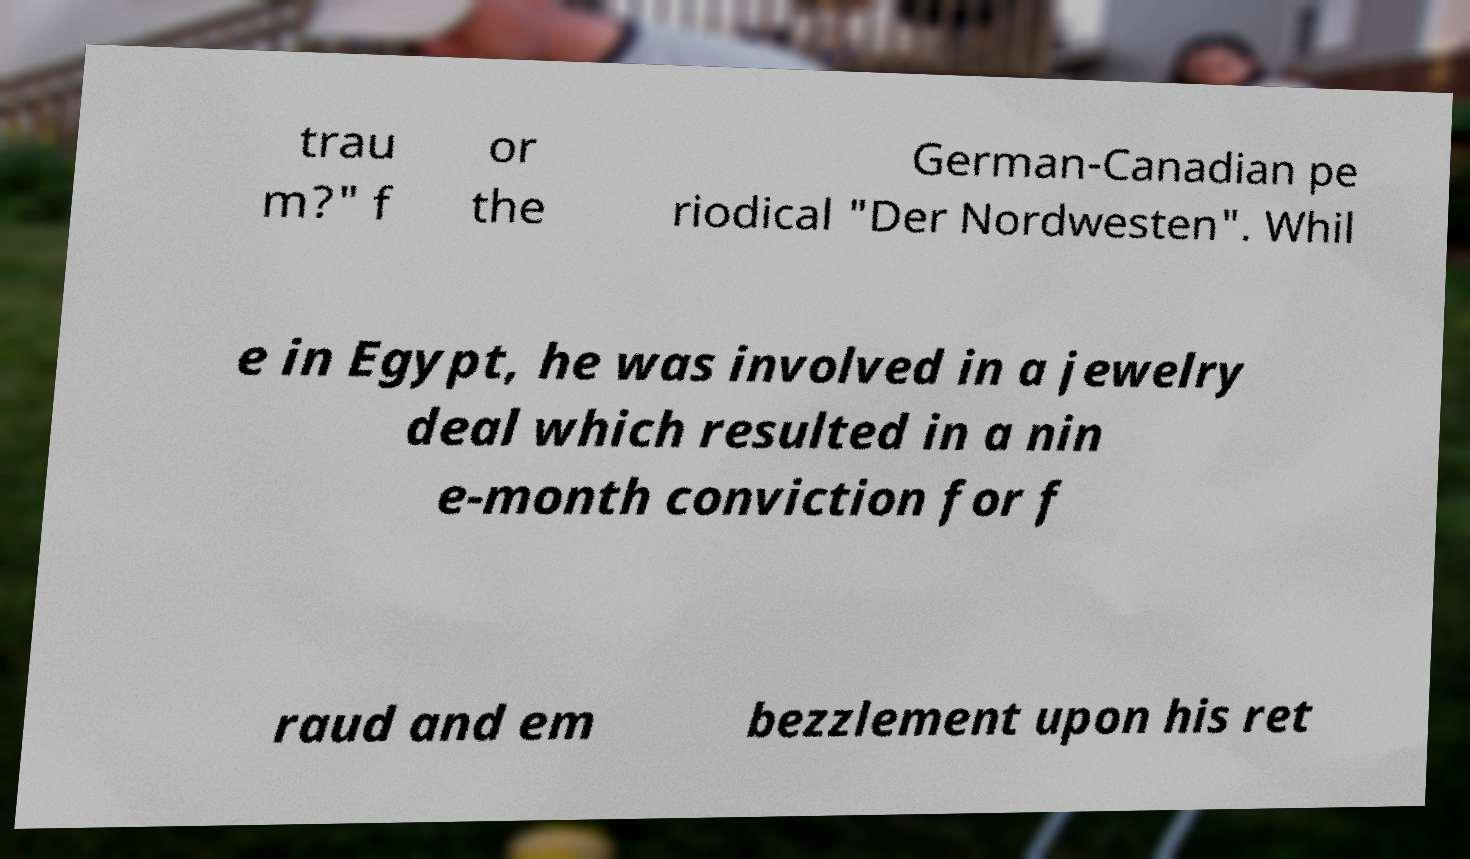Could you assist in decoding the text presented in this image and type it out clearly? trau m?" f or the German-Canadian pe riodical "Der Nordwesten". Whil e in Egypt, he was involved in a jewelry deal which resulted in a nin e-month conviction for f raud and em bezzlement upon his ret 